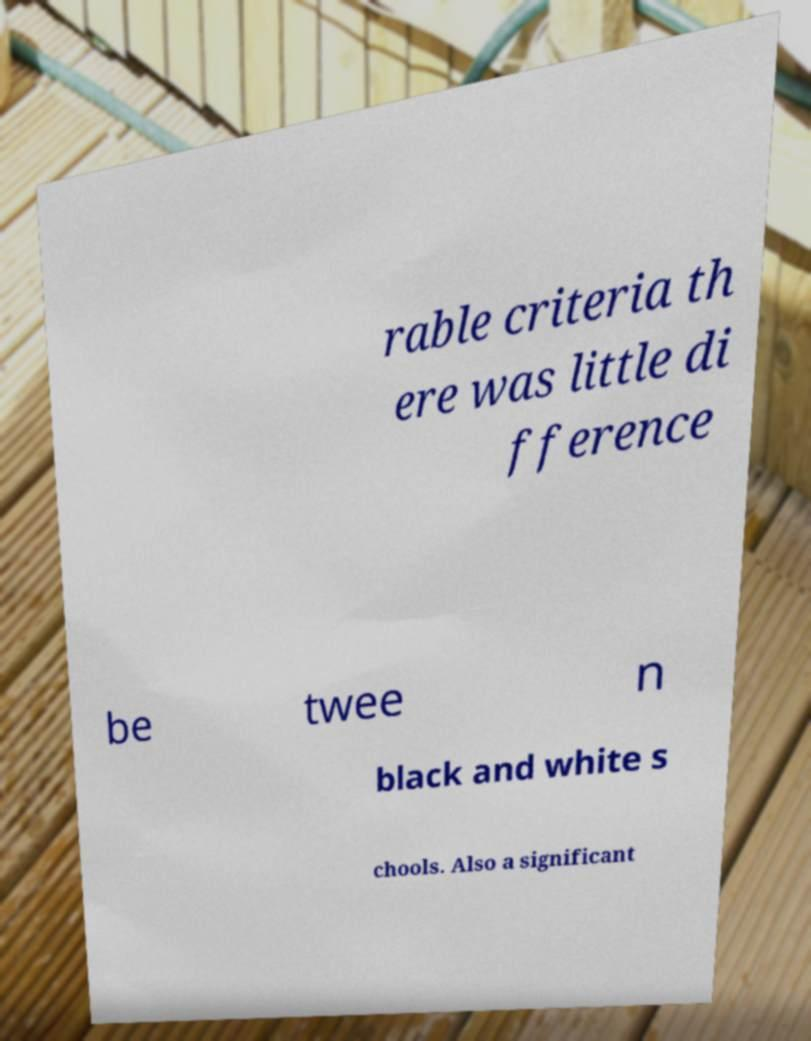Could you extract and type out the text from this image? rable criteria th ere was little di fference be twee n black and white s chools. Also a significant 